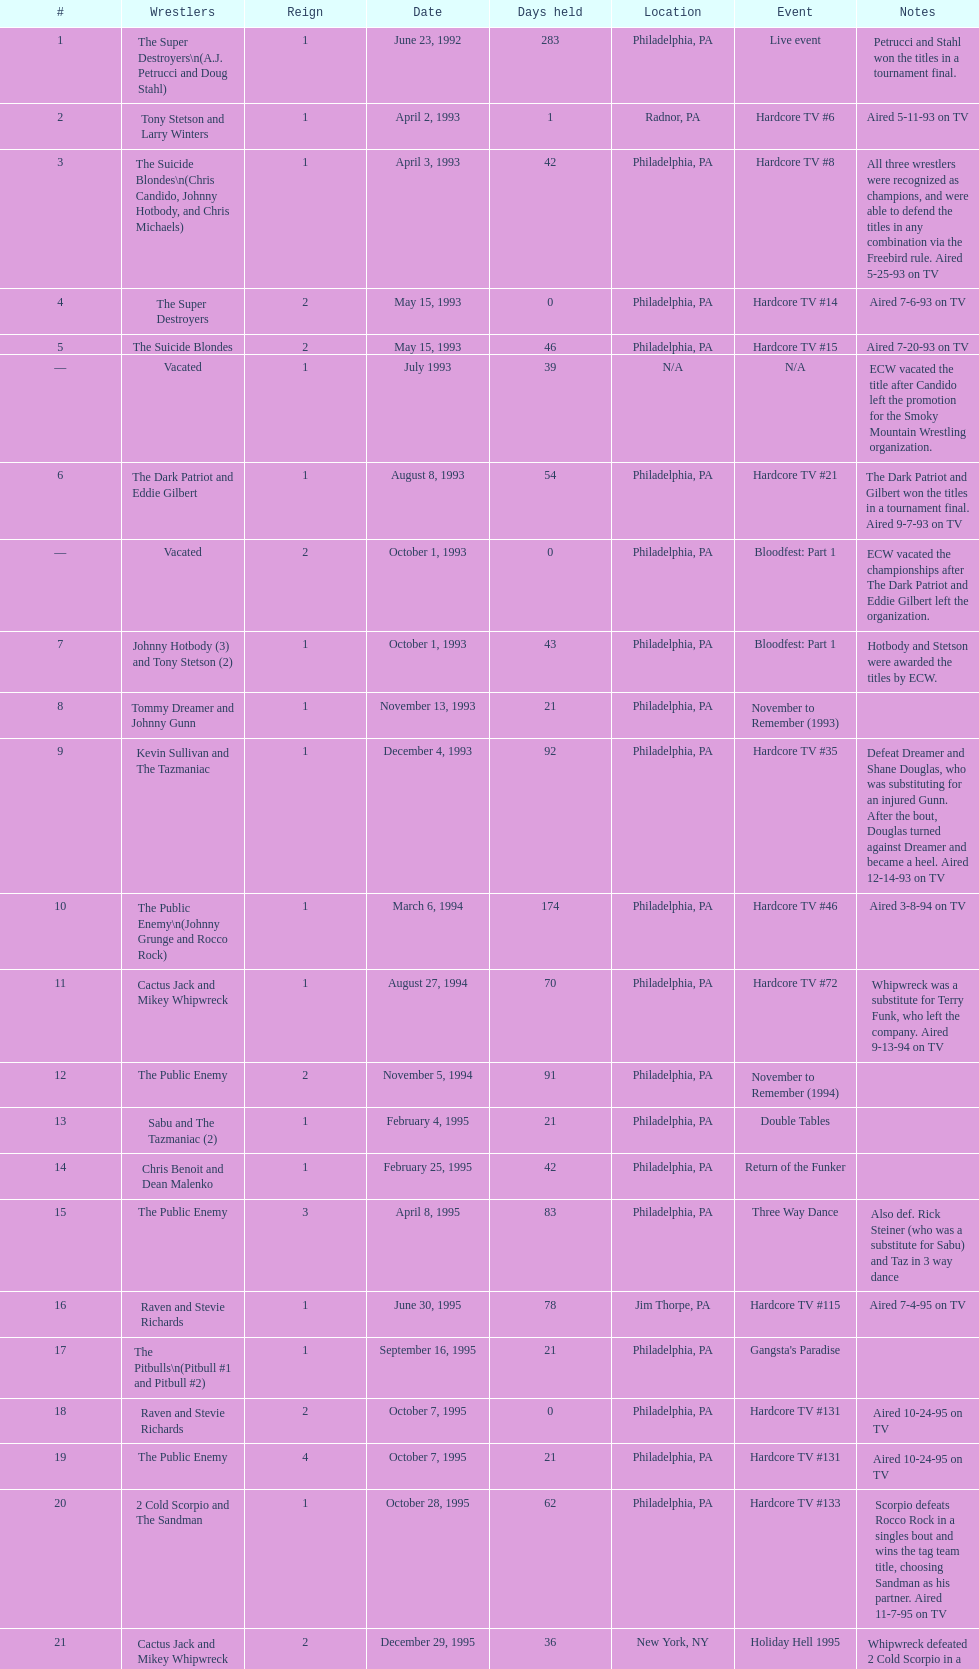Following hardcore tv #15, which event occurs next? Hardcore TV #21. 